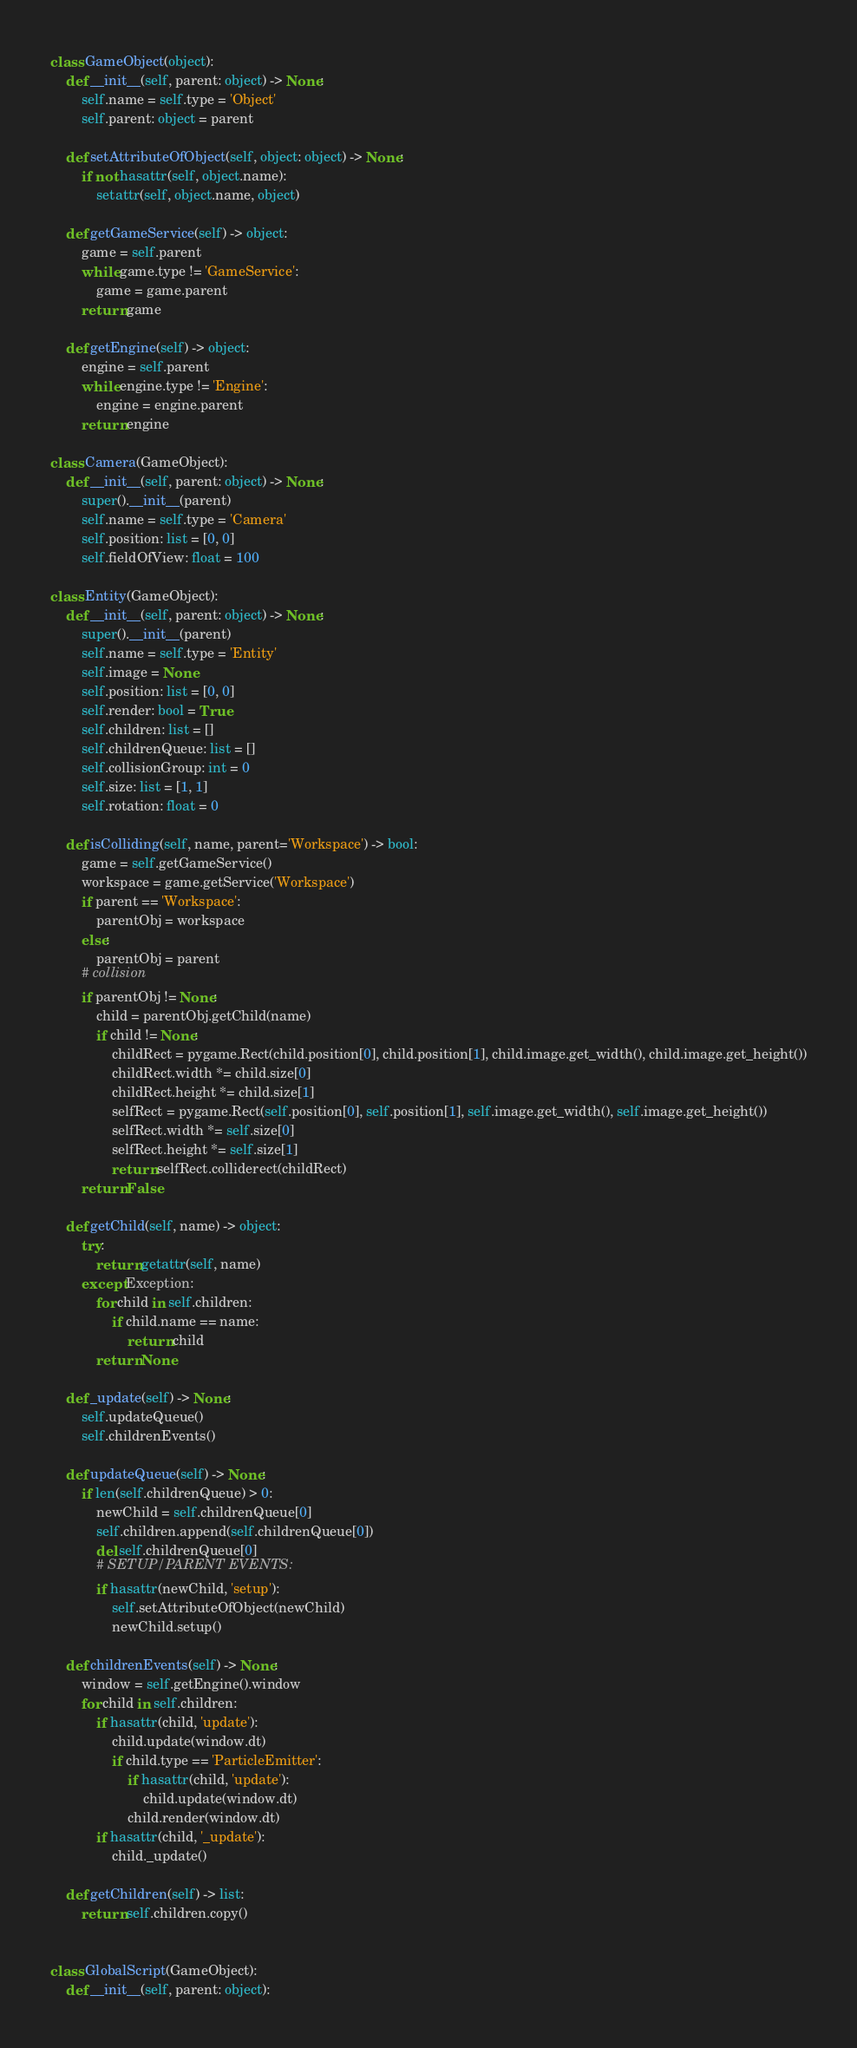<code> <loc_0><loc_0><loc_500><loc_500><_Python_>
class GameObject(object):
    def __init__(self, parent: object) -> None:
        self.name = self.type = 'Object'
        self.parent: object = parent

    def setAttributeOfObject(self, object: object) -> None:
        if not hasattr(self, object.name):
            setattr(self, object.name, object)

    def getGameService(self) -> object:
        game = self.parent
        while game.type != 'GameService':
            game = game.parent
        return game

    def getEngine(self) -> object:
        engine = self.parent
        while engine.type != 'Engine':
            engine = engine.parent
        return engine

class Camera(GameObject):
    def __init__(self, parent: object) -> None:
        super().__init__(parent)
        self.name = self.type = 'Camera'
        self.position: list = [0, 0]
        self.fieldOfView: float = 100

class Entity(GameObject):
    def __init__(self, parent: object) -> None:
        super().__init__(parent)
        self.name = self.type = 'Entity'
        self.image = None
        self.position: list = [0, 0]
        self.render: bool = True
        self.children: list = []
        self.childrenQueue: list = []
        self.collisionGroup: int = 0
        self.size: list = [1, 1]
        self.rotation: float = 0

    def isColliding(self, name, parent='Workspace') -> bool:
        game = self.getGameService()
        workspace = game.getService('Workspace')
        if parent == 'Workspace':
            parentObj = workspace
        else:
            parentObj = parent
        # collision
        if parentObj != None:
            child = parentObj.getChild(name)
            if child != None:
                childRect = pygame.Rect(child.position[0], child.position[1], child.image.get_width(), child.image.get_height())
                childRect.width *= child.size[0]
                childRect.height *= child.size[1]
                selfRect = pygame.Rect(self.position[0], self.position[1], self.image.get_width(), self.image.get_height())
                selfRect.width *= self.size[0]
                selfRect.height *= self.size[1]
                return selfRect.colliderect(childRect)
        return False

    def getChild(self, name) -> object:
        try:
            return getattr(self, name)
        except Exception:
            for child in self.children:
                if child.name == name:
                    return child
            return None

    def _update(self) -> None:
        self.updateQueue()
        self.childrenEvents()

    def updateQueue(self) -> None:
        if len(self.childrenQueue) > 0:
            newChild = self.childrenQueue[0]
            self.children.append(self.childrenQueue[0])
            del self.childrenQueue[0]
            # SETUP/PARENT EVENTS:
            if hasattr(newChild, 'setup'):
                self.setAttributeOfObject(newChild)
                newChild.setup()

    def childrenEvents(self) -> None:
        window = self.getEngine().window
        for child in self.children:
            if hasattr(child, 'update'):
                child.update(window.dt)
                if child.type == 'ParticleEmitter':
                    if hasattr(child, 'update'):
                        child.update(window.dt)
                    child.render(window.dt)
            if hasattr(child, '_update'):
                child._update()

    def getChildren(self) -> list:
        return self.children.copy()


class GlobalScript(GameObject):
    def __init__(self, parent: object):</code> 